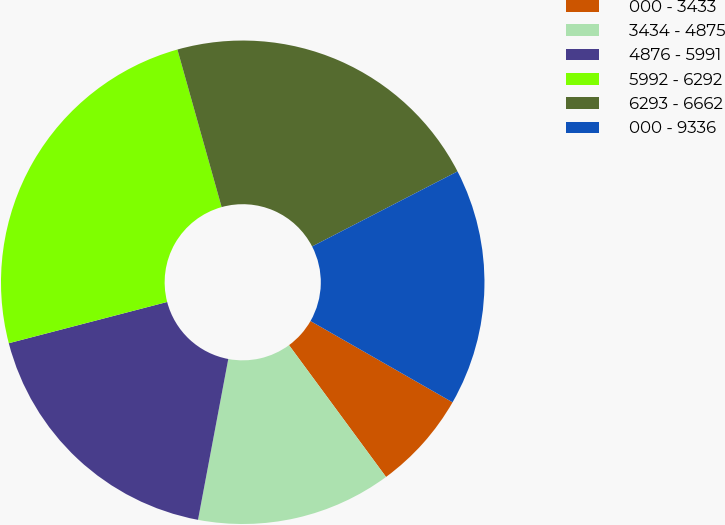<chart> <loc_0><loc_0><loc_500><loc_500><pie_chart><fcel>000 - 3433<fcel>3434 - 4875<fcel>4876 - 5991<fcel>5992 - 6292<fcel>6293 - 6662<fcel>000 - 9336<nl><fcel>6.63%<fcel>13.06%<fcel>17.98%<fcel>24.7%<fcel>21.77%<fcel>15.85%<nl></chart> 